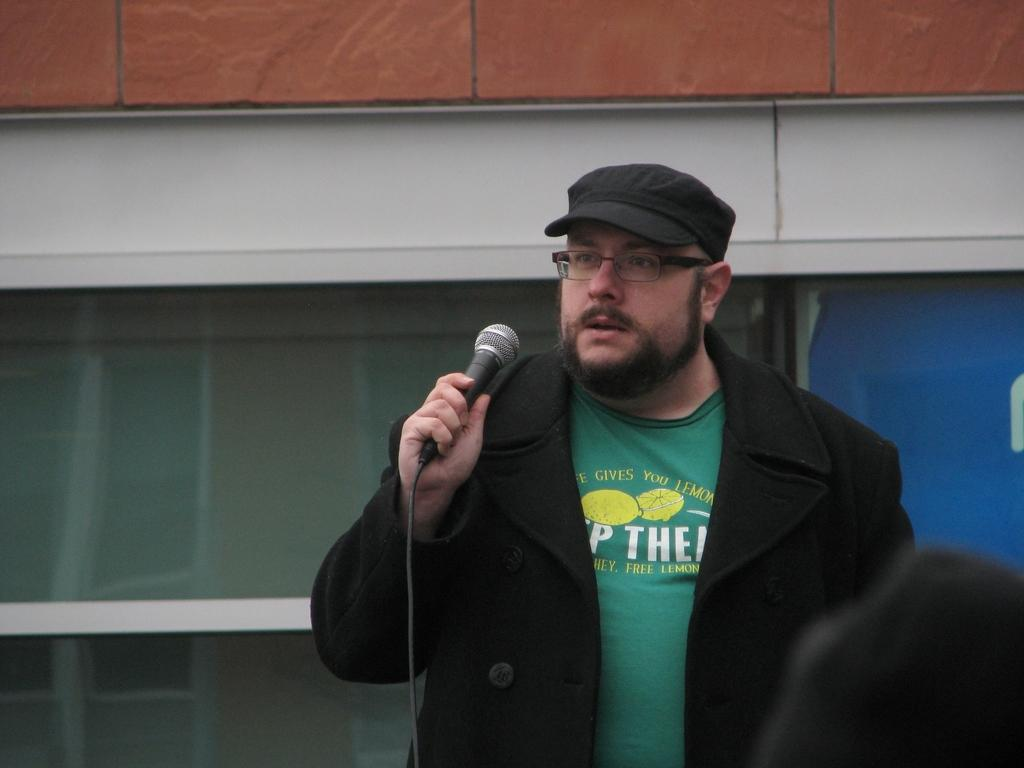What is the main subject of the image? The main subject of the image is a man. Can you describe the man's attire in the image? The man is wearing a black color blazer and a cap. What accessory is the man wearing in the image? The man is wearing spectacles. What is the man holding in his hand in the image? The man is holding a microphone in his hand. What health issue is the man addressing in the image? The image does not provide any information about a health issue or the man addressing one. 